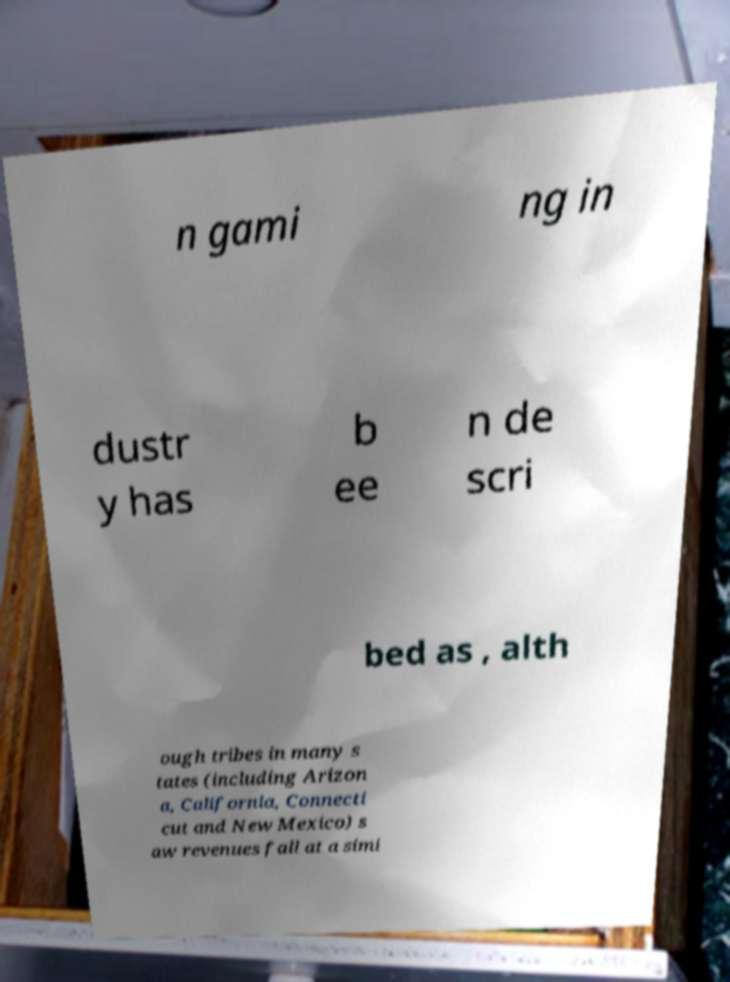Please read and relay the text visible in this image. What does it say? n gami ng in dustr y has b ee n de scri bed as , alth ough tribes in many s tates (including Arizon a, California, Connecti cut and New Mexico) s aw revenues fall at a simi 